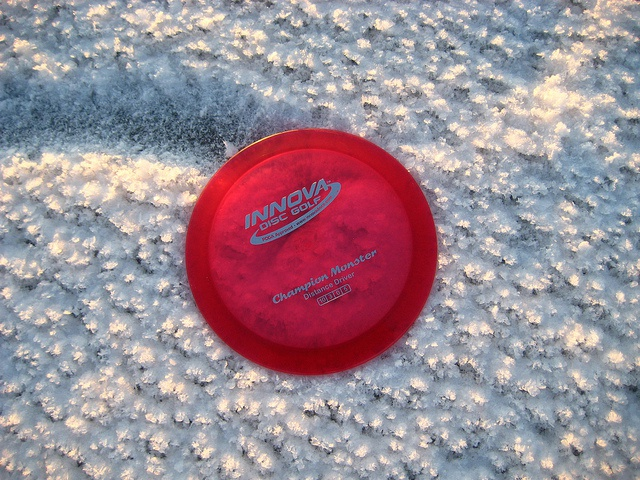Describe the objects in this image and their specific colors. I can see a frisbee in darkgray, brown, and maroon tones in this image. 